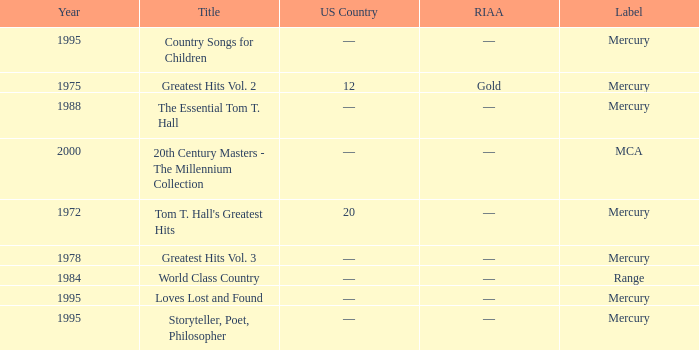What label had the album after 1978? Range, Mercury, Mercury, Mercury, Mercury, MCA. 